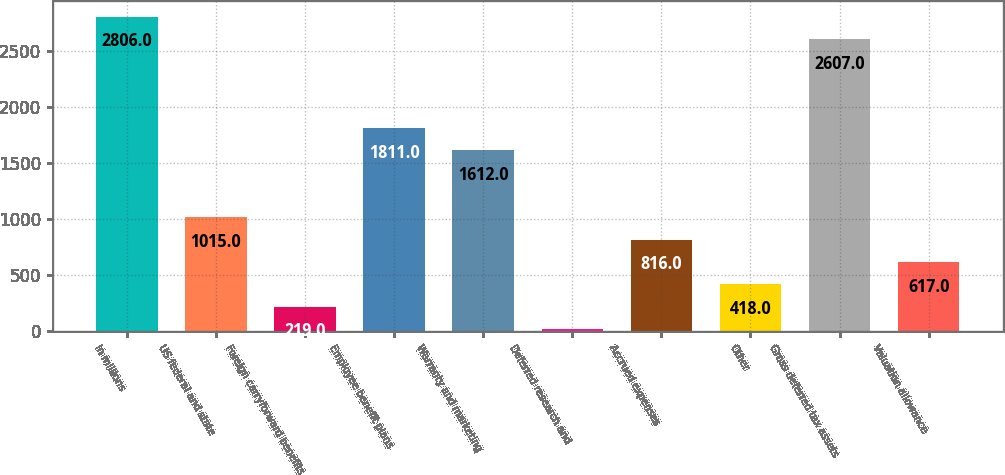<chart> <loc_0><loc_0><loc_500><loc_500><bar_chart><fcel>In millions<fcel>US federal and state<fcel>Foreign carryforward benefits<fcel>Employee benefit plans<fcel>Warranty and marketing<fcel>Deferred research and<fcel>Accrued expenses<fcel>Other<fcel>Gross deferred tax assets<fcel>Valuation allowance<nl><fcel>2806<fcel>1015<fcel>219<fcel>1811<fcel>1612<fcel>20<fcel>816<fcel>418<fcel>2607<fcel>617<nl></chart> 